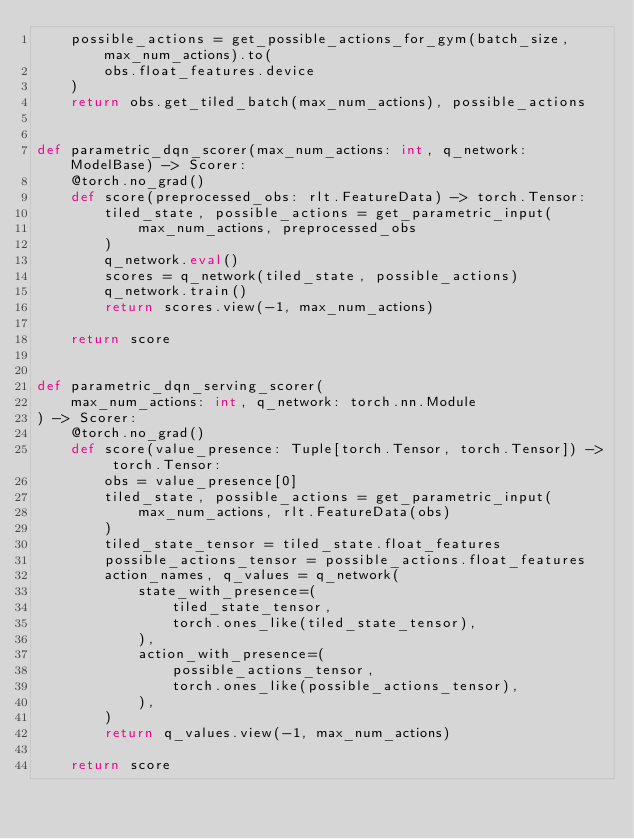<code> <loc_0><loc_0><loc_500><loc_500><_Python_>    possible_actions = get_possible_actions_for_gym(batch_size, max_num_actions).to(
        obs.float_features.device
    )
    return obs.get_tiled_batch(max_num_actions), possible_actions


def parametric_dqn_scorer(max_num_actions: int, q_network: ModelBase) -> Scorer:
    @torch.no_grad()
    def score(preprocessed_obs: rlt.FeatureData) -> torch.Tensor:
        tiled_state, possible_actions = get_parametric_input(
            max_num_actions, preprocessed_obs
        )
        q_network.eval()
        scores = q_network(tiled_state, possible_actions)
        q_network.train()
        return scores.view(-1, max_num_actions)

    return score


def parametric_dqn_serving_scorer(
    max_num_actions: int, q_network: torch.nn.Module
) -> Scorer:
    @torch.no_grad()
    def score(value_presence: Tuple[torch.Tensor, torch.Tensor]) -> torch.Tensor:
        obs = value_presence[0]
        tiled_state, possible_actions = get_parametric_input(
            max_num_actions, rlt.FeatureData(obs)
        )
        tiled_state_tensor = tiled_state.float_features
        possible_actions_tensor = possible_actions.float_features
        action_names, q_values = q_network(
            state_with_presence=(
                tiled_state_tensor,
                torch.ones_like(tiled_state_tensor),
            ),
            action_with_presence=(
                possible_actions_tensor,
                torch.ones_like(possible_actions_tensor),
            ),
        )
        return q_values.view(-1, max_num_actions)

    return score
</code> 